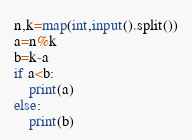Convert code to text. <code><loc_0><loc_0><loc_500><loc_500><_Python_>n,k=map(int,input().split())
a=n%k
b=k-a
if a<b:
    print(a)
else:
    print(b)</code> 